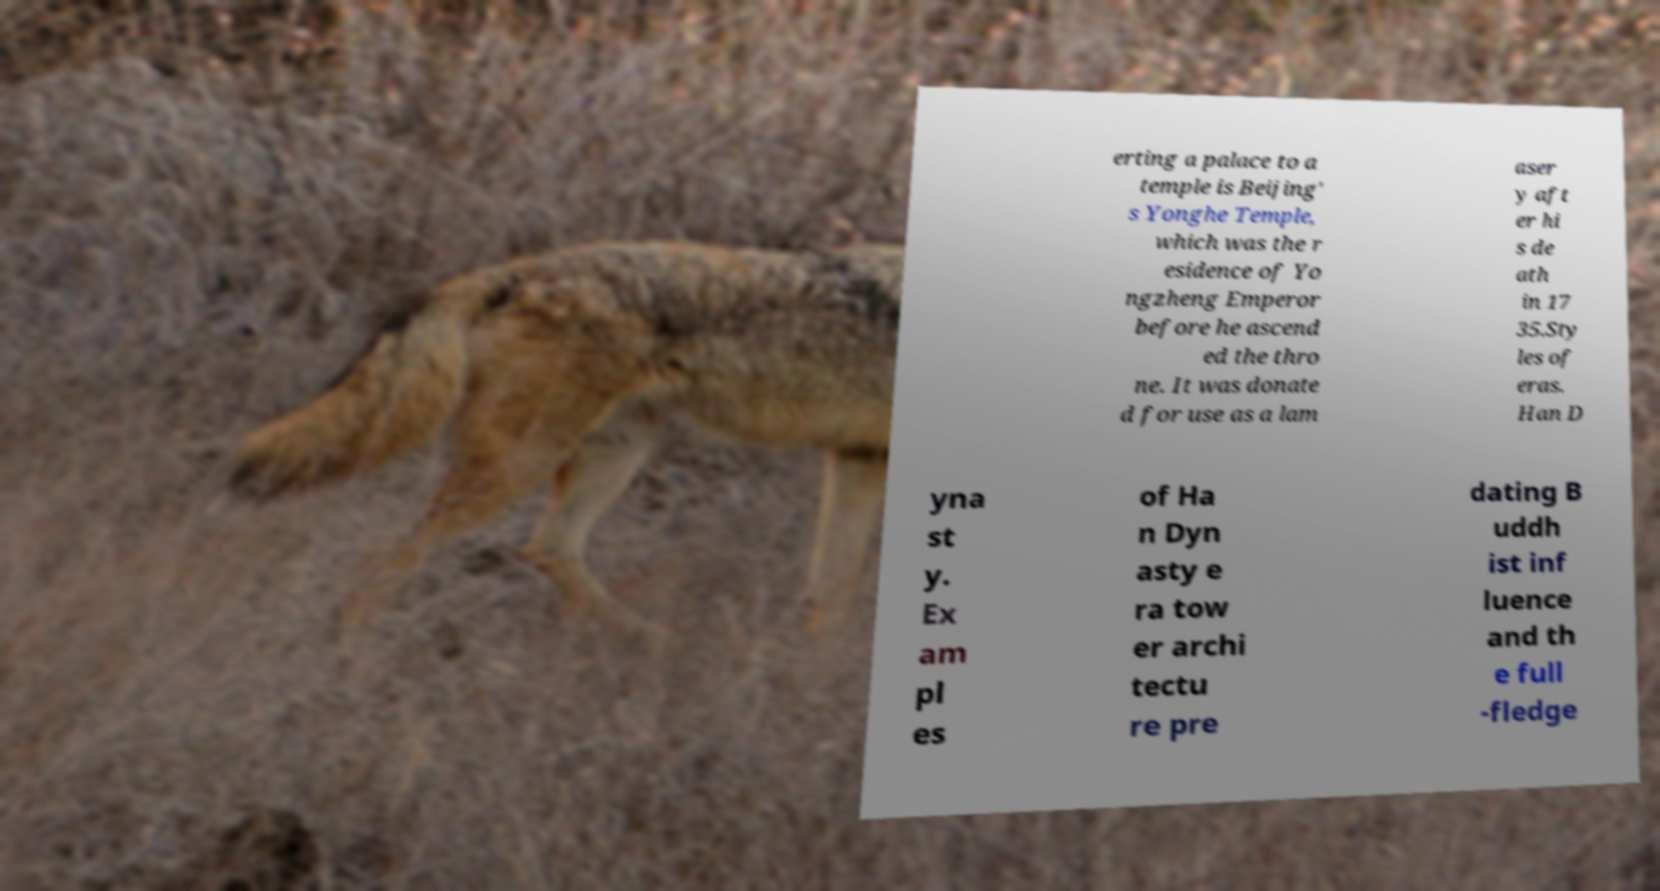I need the written content from this picture converted into text. Can you do that? erting a palace to a temple is Beijing' s Yonghe Temple, which was the r esidence of Yo ngzheng Emperor before he ascend ed the thro ne. It was donate d for use as a lam aser y aft er hi s de ath in 17 35.Sty les of eras. Han D yna st y. Ex am pl es of Ha n Dyn asty e ra tow er archi tectu re pre dating B uddh ist inf luence and th e full -fledge 